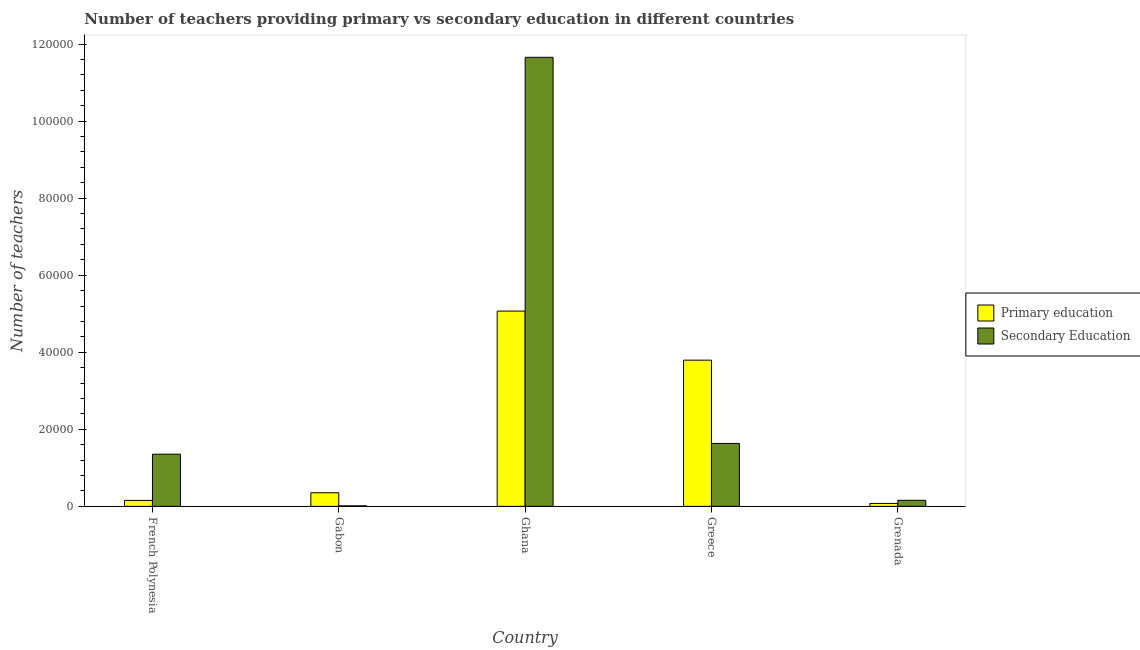Are the number of bars on each tick of the X-axis equal?
Your answer should be compact. Yes. How many bars are there on the 1st tick from the left?
Make the answer very short. 2. What is the label of the 3rd group of bars from the left?
Your answer should be compact. Ghana. In how many cases, is the number of bars for a given country not equal to the number of legend labels?
Your response must be concise. 0. What is the number of primary teachers in Ghana?
Offer a terse response. 5.07e+04. Across all countries, what is the maximum number of secondary teachers?
Your response must be concise. 1.17e+05. Across all countries, what is the minimum number of secondary teachers?
Provide a succinct answer. 131. In which country was the number of secondary teachers maximum?
Provide a short and direct response. Ghana. In which country was the number of primary teachers minimum?
Give a very brief answer. Grenada. What is the total number of secondary teachers in the graph?
Your response must be concise. 1.48e+05. What is the difference between the number of primary teachers in Greece and that in Grenada?
Ensure brevity in your answer.  3.72e+04. What is the difference between the number of primary teachers in Grenada and the number of secondary teachers in Greece?
Give a very brief answer. -1.56e+04. What is the average number of secondary teachers per country?
Keep it short and to the point. 2.96e+04. What is the difference between the number of primary teachers and number of secondary teachers in French Polynesia?
Make the answer very short. -1.20e+04. What is the ratio of the number of primary teachers in Gabon to that in Grenada?
Make the answer very short. 4.64. Is the number of secondary teachers in French Polynesia less than that in Ghana?
Ensure brevity in your answer.  Yes. Is the difference between the number of primary teachers in French Polynesia and Gabon greater than the difference between the number of secondary teachers in French Polynesia and Gabon?
Ensure brevity in your answer.  No. What is the difference between the highest and the second highest number of secondary teachers?
Your response must be concise. 1.00e+05. What is the difference between the highest and the lowest number of secondary teachers?
Your response must be concise. 1.16e+05. In how many countries, is the number of primary teachers greater than the average number of primary teachers taken over all countries?
Your answer should be compact. 2. What does the 2nd bar from the left in Ghana represents?
Your answer should be very brief. Secondary Education. What does the 2nd bar from the right in Greece represents?
Your answer should be compact. Primary education. How many countries are there in the graph?
Your answer should be very brief. 5. What is the difference between two consecutive major ticks on the Y-axis?
Make the answer very short. 2.00e+04. Are the values on the major ticks of Y-axis written in scientific E-notation?
Make the answer very short. No. Does the graph contain grids?
Ensure brevity in your answer.  No. Where does the legend appear in the graph?
Offer a very short reply. Center right. How many legend labels are there?
Make the answer very short. 2. What is the title of the graph?
Provide a succinct answer. Number of teachers providing primary vs secondary education in different countries. What is the label or title of the X-axis?
Make the answer very short. Country. What is the label or title of the Y-axis?
Ensure brevity in your answer.  Number of teachers. What is the Number of teachers of Primary education in French Polynesia?
Offer a very short reply. 1544. What is the Number of teachers of Secondary Education in French Polynesia?
Offer a terse response. 1.35e+04. What is the Number of teachers in Primary education in Gabon?
Make the answer very short. 3526. What is the Number of teachers in Secondary Education in Gabon?
Ensure brevity in your answer.  131. What is the Number of teachers of Primary education in Ghana?
Provide a succinct answer. 5.07e+04. What is the Number of teachers in Secondary Education in Ghana?
Your response must be concise. 1.17e+05. What is the Number of teachers in Primary education in Greece?
Give a very brief answer. 3.79e+04. What is the Number of teachers of Secondary Education in Greece?
Make the answer very short. 1.63e+04. What is the Number of teachers in Primary education in Grenada?
Offer a terse response. 760. What is the Number of teachers of Secondary Education in Grenada?
Your response must be concise. 1567. Across all countries, what is the maximum Number of teachers of Primary education?
Make the answer very short. 5.07e+04. Across all countries, what is the maximum Number of teachers in Secondary Education?
Provide a succinct answer. 1.17e+05. Across all countries, what is the minimum Number of teachers in Primary education?
Offer a terse response. 760. Across all countries, what is the minimum Number of teachers of Secondary Education?
Keep it short and to the point. 131. What is the total Number of teachers in Primary education in the graph?
Offer a very short reply. 9.45e+04. What is the total Number of teachers in Secondary Education in the graph?
Your response must be concise. 1.48e+05. What is the difference between the Number of teachers in Primary education in French Polynesia and that in Gabon?
Your response must be concise. -1982. What is the difference between the Number of teachers of Secondary Education in French Polynesia and that in Gabon?
Provide a succinct answer. 1.34e+04. What is the difference between the Number of teachers of Primary education in French Polynesia and that in Ghana?
Offer a terse response. -4.91e+04. What is the difference between the Number of teachers in Secondary Education in French Polynesia and that in Ghana?
Provide a succinct answer. -1.03e+05. What is the difference between the Number of teachers in Primary education in French Polynesia and that in Greece?
Keep it short and to the point. -3.64e+04. What is the difference between the Number of teachers of Secondary Education in French Polynesia and that in Greece?
Give a very brief answer. -2790. What is the difference between the Number of teachers in Primary education in French Polynesia and that in Grenada?
Make the answer very short. 784. What is the difference between the Number of teachers of Secondary Education in French Polynesia and that in Grenada?
Your answer should be very brief. 1.20e+04. What is the difference between the Number of teachers in Primary education in Gabon and that in Ghana?
Your response must be concise. -4.72e+04. What is the difference between the Number of teachers in Secondary Education in Gabon and that in Ghana?
Your response must be concise. -1.16e+05. What is the difference between the Number of teachers of Primary education in Gabon and that in Greece?
Ensure brevity in your answer.  -3.44e+04. What is the difference between the Number of teachers in Secondary Education in Gabon and that in Greece?
Offer a terse response. -1.62e+04. What is the difference between the Number of teachers in Primary education in Gabon and that in Grenada?
Provide a short and direct response. 2766. What is the difference between the Number of teachers in Secondary Education in Gabon and that in Grenada?
Your response must be concise. -1436. What is the difference between the Number of teachers of Primary education in Ghana and that in Greece?
Offer a very short reply. 1.27e+04. What is the difference between the Number of teachers in Secondary Education in Ghana and that in Greece?
Your answer should be compact. 1.00e+05. What is the difference between the Number of teachers of Primary education in Ghana and that in Grenada?
Ensure brevity in your answer.  4.99e+04. What is the difference between the Number of teachers in Secondary Education in Ghana and that in Grenada?
Provide a succinct answer. 1.15e+05. What is the difference between the Number of teachers of Primary education in Greece and that in Grenada?
Make the answer very short. 3.72e+04. What is the difference between the Number of teachers of Secondary Education in Greece and that in Grenada?
Give a very brief answer. 1.48e+04. What is the difference between the Number of teachers of Primary education in French Polynesia and the Number of teachers of Secondary Education in Gabon?
Your response must be concise. 1413. What is the difference between the Number of teachers in Primary education in French Polynesia and the Number of teachers in Secondary Education in Ghana?
Offer a terse response. -1.15e+05. What is the difference between the Number of teachers in Primary education in French Polynesia and the Number of teachers in Secondary Education in Greece?
Your response must be concise. -1.48e+04. What is the difference between the Number of teachers in Primary education in Gabon and the Number of teachers in Secondary Education in Ghana?
Keep it short and to the point. -1.13e+05. What is the difference between the Number of teachers in Primary education in Gabon and the Number of teachers in Secondary Education in Greece?
Ensure brevity in your answer.  -1.28e+04. What is the difference between the Number of teachers in Primary education in Gabon and the Number of teachers in Secondary Education in Grenada?
Your answer should be compact. 1959. What is the difference between the Number of teachers in Primary education in Ghana and the Number of teachers in Secondary Education in Greece?
Give a very brief answer. 3.44e+04. What is the difference between the Number of teachers in Primary education in Ghana and the Number of teachers in Secondary Education in Grenada?
Your answer should be very brief. 4.91e+04. What is the difference between the Number of teachers of Primary education in Greece and the Number of teachers of Secondary Education in Grenada?
Your answer should be very brief. 3.64e+04. What is the average Number of teachers of Primary education per country?
Keep it short and to the point. 1.89e+04. What is the average Number of teachers in Secondary Education per country?
Provide a short and direct response. 2.96e+04. What is the difference between the Number of teachers of Primary education and Number of teachers of Secondary Education in French Polynesia?
Provide a succinct answer. -1.20e+04. What is the difference between the Number of teachers of Primary education and Number of teachers of Secondary Education in Gabon?
Ensure brevity in your answer.  3395. What is the difference between the Number of teachers in Primary education and Number of teachers in Secondary Education in Ghana?
Offer a terse response. -6.59e+04. What is the difference between the Number of teachers in Primary education and Number of teachers in Secondary Education in Greece?
Keep it short and to the point. 2.16e+04. What is the difference between the Number of teachers of Primary education and Number of teachers of Secondary Education in Grenada?
Ensure brevity in your answer.  -807. What is the ratio of the Number of teachers in Primary education in French Polynesia to that in Gabon?
Your response must be concise. 0.44. What is the ratio of the Number of teachers of Secondary Education in French Polynesia to that in Gabon?
Keep it short and to the point. 103.35. What is the ratio of the Number of teachers in Primary education in French Polynesia to that in Ghana?
Ensure brevity in your answer.  0.03. What is the ratio of the Number of teachers in Secondary Education in French Polynesia to that in Ghana?
Offer a terse response. 0.12. What is the ratio of the Number of teachers of Primary education in French Polynesia to that in Greece?
Ensure brevity in your answer.  0.04. What is the ratio of the Number of teachers in Secondary Education in French Polynesia to that in Greece?
Your answer should be very brief. 0.83. What is the ratio of the Number of teachers in Primary education in French Polynesia to that in Grenada?
Offer a very short reply. 2.03. What is the ratio of the Number of teachers in Secondary Education in French Polynesia to that in Grenada?
Offer a very short reply. 8.64. What is the ratio of the Number of teachers in Primary education in Gabon to that in Ghana?
Provide a short and direct response. 0.07. What is the ratio of the Number of teachers of Secondary Education in Gabon to that in Ghana?
Your answer should be very brief. 0. What is the ratio of the Number of teachers of Primary education in Gabon to that in Greece?
Offer a terse response. 0.09. What is the ratio of the Number of teachers of Secondary Education in Gabon to that in Greece?
Make the answer very short. 0.01. What is the ratio of the Number of teachers in Primary education in Gabon to that in Grenada?
Your answer should be compact. 4.64. What is the ratio of the Number of teachers in Secondary Education in Gabon to that in Grenada?
Offer a very short reply. 0.08. What is the ratio of the Number of teachers of Primary education in Ghana to that in Greece?
Ensure brevity in your answer.  1.34. What is the ratio of the Number of teachers of Secondary Education in Ghana to that in Greece?
Make the answer very short. 7.14. What is the ratio of the Number of teachers of Primary education in Ghana to that in Grenada?
Provide a succinct answer. 66.69. What is the ratio of the Number of teachers of Secondary Education in Ghana to that in Grenada?
Offer a terse response. 74.38. What is the ratio of the Number of teachers in Primary education in Greece to that in Grenada?
Offer a terse response. 49.93. What is the ratio of the Number of teachers of Secondary Education in Greece to that in Grenada?
Provide a succinct answer. 10.42. What is the difference between the highest and the second highest Number of teachers in Primary education?
Keep it short and to the point. 1.27e+04. What is the difference between the highest and the second highest Number of teachers of Secondary Education?
Give a very brief answer. 1.00e+05. What is the difference between the highest and the lowest Number of teachers of Primary education?
Your answer should be compact. 4.99e+04. What is the difference between the highest and the lowest Number of teachers of Secondary Education?
Offer a very short reply. 1.16e+05. 